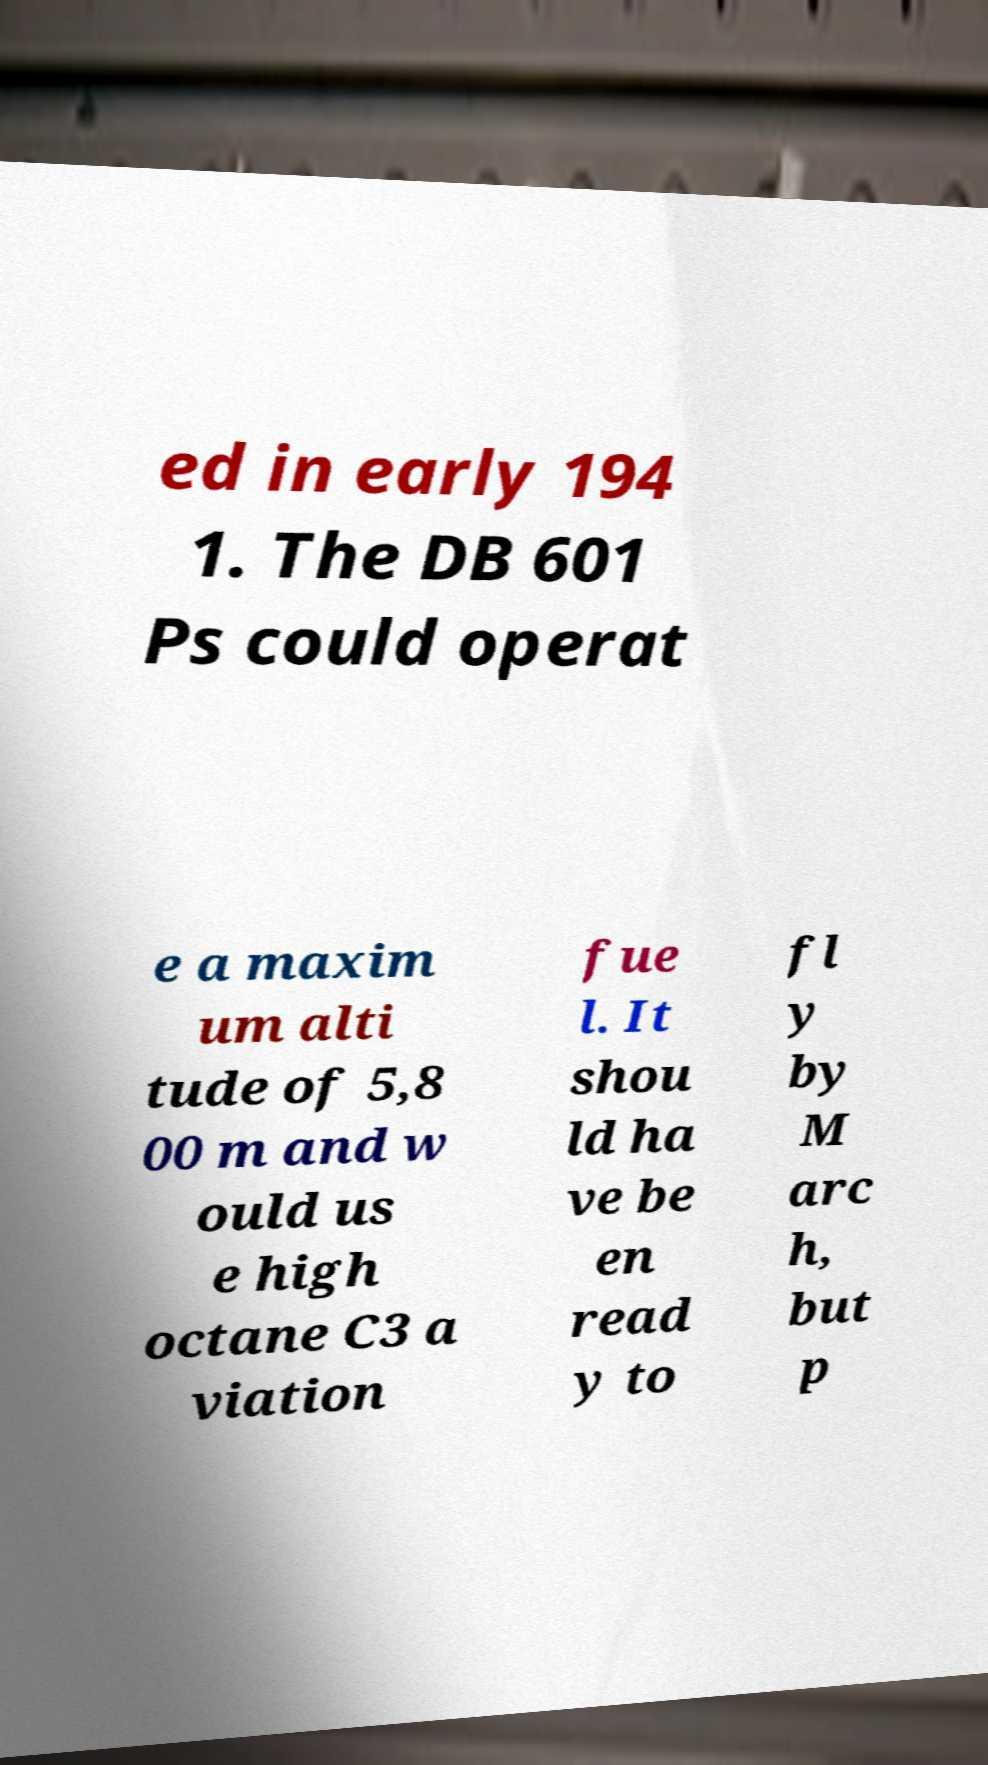I need the written content from this picture converted into text. Can you do that? ed in early 194 1. The DB 601 Ps could operat e a maxim um alti tude of 5,8 00 m and w ould us e high octane C3 a viation fue l. It shou ld ha ve be en read y to fl y by M arc h, but p 